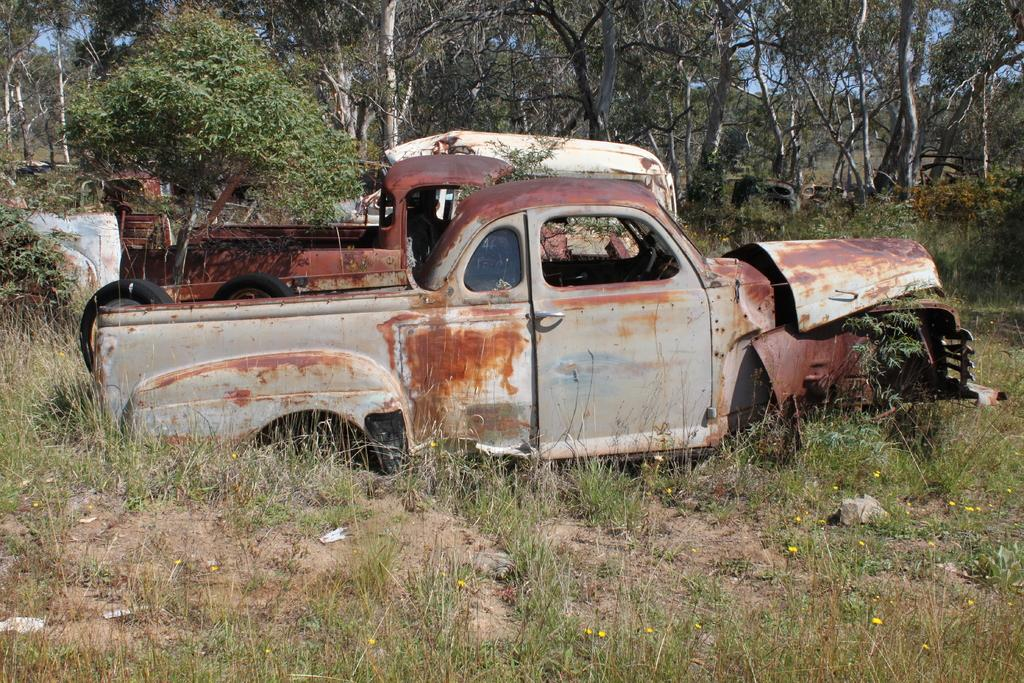What type of vehicles can be seen in the image? There are damaged vehicles in the image. Where are the vehicles located? The vehicles are on the land. What type of vegetation is visible at the bottom of the image? There is grass at the bottom of the image. What can be seen in the background of the image? There are trees and the sky visible in the background of the image. Who gave the stranger their approval to order the damaged vehicles in the image? There is no stranger or approval process mentioned in the image; it simply shows damaged vehicles on the land. 